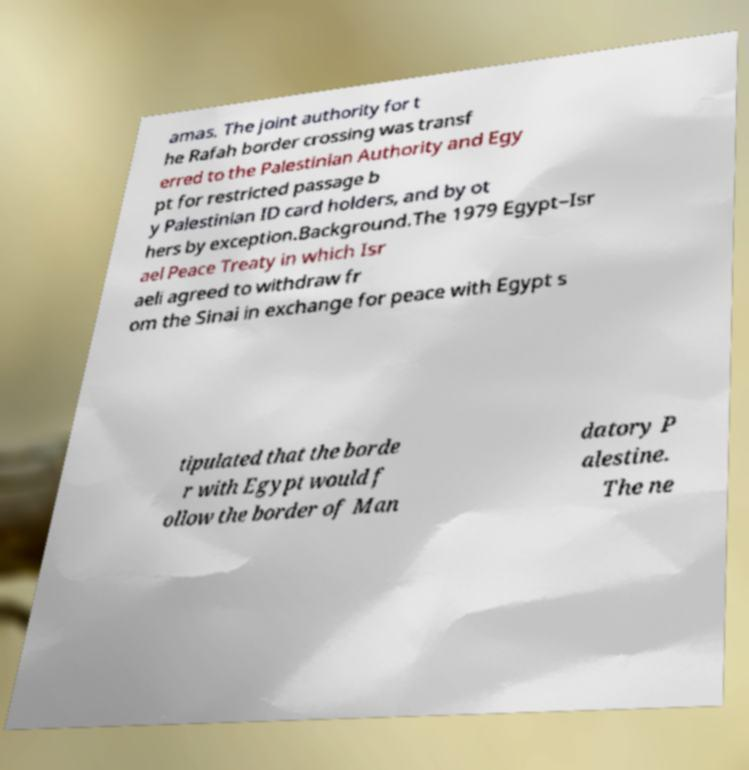What messages or text are displayed in this image? I need them in a readable, typed format. amas. The joint authority for t he Rafah border crossing was transf erred to the Palestinian Authority and Egy pt for restricted passage b y Palestinian ID card holders, and by ot hers by exception.Background.The 1979 Egypt–Isr ael Peace Treaty in which Isr aeli agreed to withdraw fr om the Sinai in exchange for peace with Egypt s tipulated that the borde r with Egypt would f ollow the border of Man datory P alestine. The ne 